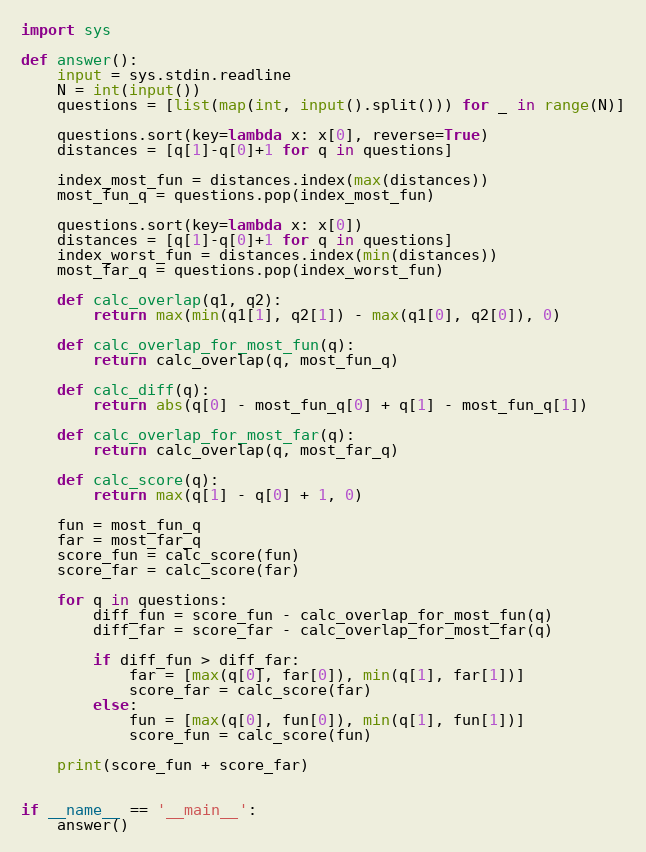Convert code to text. <code><loc_0><loc_0><loc_500><loc_500><_Python_>import sys

def answer():
    input = sys.stdin.readline
    N = int(input())
    questions = [list(map(int, input().split())) for _ in range(N)]

    questions.sort(key=lambda x: x[0], reverse=True)
    distances = [q[1]-q[0]+1 for q in questions]

    index_most_fun = distances.index(max(distances))
    most_fun_q = questions.pop(index_most_fun)

    questions.sort(key=lambda x: x[0])
    distances = [q[1]-q[0]+1 for q in questions]
    index_worst_fun = distances.index(min(distances))
    most_far_q = questions.pop(index_worst_fun)

    def calc_overlap(q1, q2):
        return max(min(q1[1], q2[1]) - max(q1[0], q2[0]), 0)

    def calc_overlap_for_most_fun(q):
        return calc_overlap(q, most_fun_q)

    def calc_diff(q):
        return abs(q[0] - most_fun_q[0] + q[1] - most_fun_q[1])

    def calc_overlap_for_most_far(q):
        return calc_overlap(q, most_far_q)

    def calc_score(q):
        return max(q[1] - q[0] + 1, 0)

    fun = most_fun_q
    far = most_far_q
    score_fun = calc_score(fun)
    score_far = calc_score(far)

    for q in questions:
        diff_fun = score_fun - calc_overlap_for_most_fun(q)
        diff_far = score_far - calc_overlap_for_most_far(q)

        if diff_fun > diff_far:
            far = [max(q[0], far[0]), min(q[1], far[1])]
            score_far = calc_score(far)
        else:
            fun = [max(q[0], fun[0]), min(q[1], fun[1])]
            score_fun = calc_score(fun)

    print(score_fun + score_far)


if __name__ == '__main__':
    answer()
</code> 